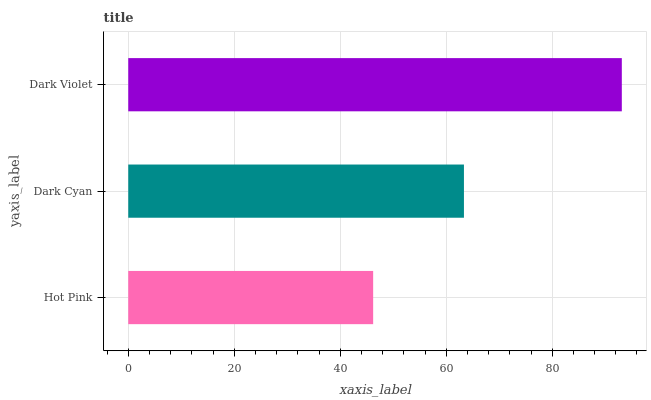Is Hot Pink the minimum?
Answer yes or no. Yes. Is Dark Violet the maximum?
Answer yes or no. Yes. Is Dark Cyan the minimum?
Answer yes or no. No. Is Dark Cyan the maximum?
Answer yes or no. No. Is Dark Cyan greater than Hot Pink?
Answer yes or no. Yes. Is Hot Pink less than Dark Cyan?
Answer yes or no. Yes. Is Hot Pink greater than Dark Cyan?
Answer yes or no. No. Is Dark Cyan less than Hot Pink?
Answer yes or no. No. Is Dark Cyan the high median?
Answer yes or no. Yes. Is Dark Cyan the low median?
Answer yes or no. Yes. Is Dark Violet the high median?
Answer yes or no. No. Is Dark Violet the low median?
Answer yes or no. No. 